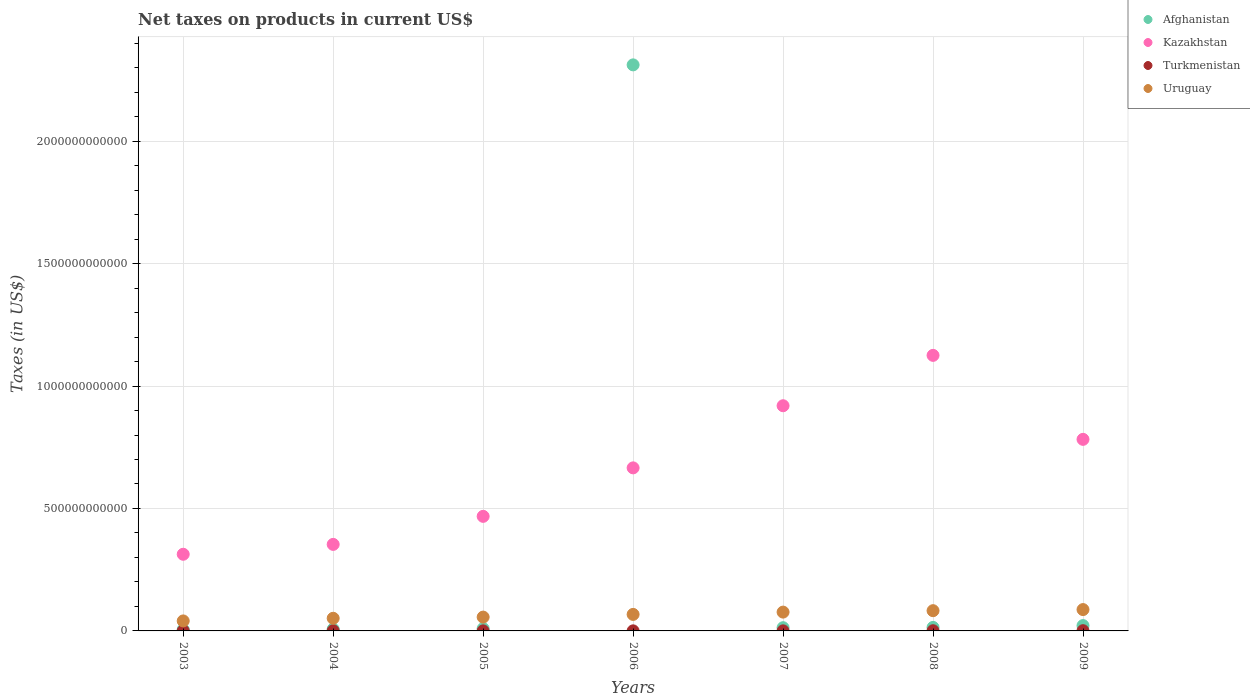What is the net taxes on products in Uruguay in 2004?
Your response must be concise. 5.16e+1. Across all years, what is the maximum net taxes on products in Uruguay?
Your answer should be compact. 8.72e+1. Across all years, what is the minimum net taxes on products in Turkmenistan?
Make the answer very short. 2.62e+08. In which year was the net taxes on products in Turkmenistan maximum?
Offer a very short reply. 2009. In which year was the net taxes on products in Uruguay minimum?
Keep it short and to the point. 2003. What is the total net taxes on products in Kazakhstan in the graph?
Offer a very short reply. 4.63e+12. What is the difference between the net taxes on products in Afghanistan in 2003 and that in 2006?
Your answer should be compact. -2.31e+12. What is the difference between the net taxes on products in Kazakhstan in 2003 and the net taxes on products in Turkmenistan in 2008?
Provide a short and direct response. 3.12e+11. What is the average net taxes on products in Kazakhstan per year?
Ensure brevity in your answer.  6.61e+11. In the year 2005, what is the difference between the net taxes on products in Kazakhstan and net taxes on products in Uruguay?
Make the answer very short. 4.11e+11. In how many years, is the net taxes on products in Kazakhstan greater than 1900000000000 US$?
Offer a terse response. 0. What is the ratio of the net taxes on products in Kazakhstan in 2008 to that in 2009?
Keep it short and to the point. 1.44. Is the net taxes on products in Turkmenistan in 2005 less than that in 2007?
Give a very brief answer. Yes. What is the difference between the highest and the second highest net taxes on products in Turkmenistan?
Your response must be concise. 8.25e+07. What is the difference between the highest and the lowest net taxes on products in Turkmenistan?
Provide a short and direct response. 6.44e+08. Is it the case that in every year, the sum of the net taxes on products in Uruguay and net taxes on products in Afghanistan  is greater than the net taxes on products in Turkmenistan?
Provide a succinct answer. Yes. Does the net taxes on products in Turkmenistan monotonically increase over the years?
Provide a short and direct response. No. Is the net taxes on products in Kazakhstan strictly greater than the net taxes on products in Uruguay over the years?
Offer a very short reply. Yes. How many years are there in the graph?
Provide a short and direct response. 7. What is the difference between two consecutive major ticks on the Y-axis?
Your answer should be compact. 5.00e+11. Does the graph contain grids?
Provide a short and direct response. Yes. Where does the legend appear in the graph?
Give a very brief answer. Top right. How many legend labels are there?
Keep it short and to the point. 4. How are the legend labels stacked?
Provide a short and direct response. Vertical. What is the title of the graph?
Your answer should be compact. Net taxes on products in current US$. Does "Palau" appear as one of the legend labels in the graph?
Your answer should be compact. No. What is the label or title of the Y-axis?
Provide a succinct answer. Taxes (in US$). What is the Taxes (in US$) in Afghanistan in 2003?
Give a very brief answer. 5.37e+09. What is the Taxes (in US$) of Kazakhstan in 2003?
Ensure brevity in your answer.  3.13e+11. What is the Taxes (in US$) in Turkmenistan in 2003?
Your answer should be compact. 6.87e+08. What is the Taxes (in US$) in Uruguay in 2003?
Keep it short and to the point. 4.08e+1. What is the Taxes (in US$) in Afghanistan in 2004?
Provide a short and direct response. 7.35e+09. What is the Taxes (in US$) in Kazakhstan in 2004?
Make the answer very short. 3.53e+11. What is the Taxes (in US$) in Turkmenistan in 2004?
Provide a succinct answer. 8.24e+08. What is the Taxes (in US$) in Uruguay in 2004?
Provide a short and direct response. 5.16e+1. What is the Taxes (in US$) in Afghanistan in 2005?
Make the answer very short. 9.45e+09. What is the Taxes (in US$) in Kazakhstan in 2005?
Make the answer very short. 4.68e+11. What is the Taxes (in US$) of Turkmenistan in 2005?
Offer a very short reply. 2.62e+08. What is the Taxes (in US$) of Uruguay in 2005?
Make the answer very short. 5.64e+1. What is the Taxes (in US$) of Afghanistan in 2006?
Provide a short and direct response. 2.31e+12. What is the Taxes (in US$) in Kazakhstan in 2006?
Your answer should be compact. 6.66e+11. What is the Taxes (in US$) in Turkmenistan in 2006?
Your answer should be compact. 3.14e+08. What is the Taxes (in US$) in Uruguay in 2006?
Provide a succinct answer. 6.74e+1. What is the Taxes (in US$) in Afghanistan in 2007?
Offer a very short reply. 1.32e+1. What is the Taxes (in US$) of Kazakhstan in 2007?
Offer a very short reply. 9.20e+11. What is the Taxes (in US$) of Turkmenistan in 2007?
Provide a short and direct response. 3.09e+08. What is the Taxes (in US$) of Uruguay in 2007?
Ensure brevity in your answer.  7.68e+1. What is the Taxes (in US$) of Afghanistan in 2008?
Provide a succinct answer. 1.43e+1. What is the Taxes (in US$) of Kazakhstan in 2008?
Keep it short and to the point. 1.13e+12. What is the Taxes (in US$) of Turkmenistan in 2008?
Your answer should be compact. 7.51e+08. What is the Taxes (in US$) in Uruguay in 2008?
Ensure brevity in your answer.  8.27e+1. What is the Taxes (in US$) in Afghanistan in 2009?
Your answer should be very brief. 2.18e+1. What is the Taxes (in US$) in Kazakhstan in 2009?
Make the answer very short. 7.82e+11. What is the Taxes (in US$) in Turkmenistan in 2009?
Offer a terse response. 9.07e+08. What is the Taxes (in US$) in Uruguay in 2009?
Offer a terse response. 8.72e+1. Across all years, what is the maximum Taxes (in US$) of Afghanistan?
Your answer should be very brief. 2.31e+12. Across all years, what is the maximum Taxes (in US$) in Kazakhstan?
Ensure brevity in your answer.  1.13e+12. Across all years, what is the maximum Taxes (in US$) of Turkmenistan?
Offer a terse response. 9.07e+08. Across all years, what is the maximum Taxes (in US$) of Uruguay?
Ensure brevity in your answer.  8.72e+1. Across all years, what is the minimum Taxes (in US$) in Afghanistan?
Give a very brief answer. 5.37e+09. Across all years, what is the minimum Taxes (in US$) in Kazakhstan?
Make the answer very short. 3.13e+11. Across all years, what is the minimum Taxes (in US$) of Turkmenistan?
Your answer should be compact. 2.62e+08. Across all years, what is the minimum Taxes (in US$) in Uruguay?
Offer a terse response. 4.08e+1. What is the total Taxes (in US$) of Afghanistan in the graph?
Make the answer very short. 2.38e+12. What is the total Taxes (in US$) of Kazakhstan in the graph?
Provide a short and direct response. 4.63e+12. What is the total Taxes (in US$) in Turkmenistan in the graph?
Provide a short and direct response. 4.05e+09. What is the total Taxes (in US$) of Uruguay in the graph?
Your answer should be compact. 4.63e+11. What is the difference between the Taxes (in US$) in Afghanistan in 2003 and that in 2004?
Your answer should be compact. -1.98e+09. What is the difference between the Taxes (in US$) in Kazakhstan in 2003 and that in 2004?
Ensure brevity in your answer.  -4.03e+1. What is the difference between the Taxes (in US$) in Turkmenistan in 2003 and that in 2004?
Offer a terse response. -1.38e+08. What is the difference between the Taxes (in US$) in Uruguay in 2003 and that in 2004?
Provide a succinct answer. -1.08e+1. What is the difference between the Taxes (in US$) of Afghanistan in 2003 and that in 2005?
Provide a succinct answer. -4.08e+09. What is the difference between the Taxes (in US$) in Kazakhstan in 2003 and that in 2005?
Ensure brevity in your answer.  -1.55e+11. What is the difference between the Taxes (in US$) of Turkmenistan in 2003 and that in 2005?
Provide a succinct answer. 4.24e+08. What is the difference between the Taxes (in US$) of Uruguay in 2003 and that in 2005?
Your response must be concise. -1.56e+1. What is the difference between the Taxes (in US$) in Afghanistan in 2003 and that in 2006?
Keep it short and to the point. -2.31e+12. What is the difference between the Taxes (in US$) in Kazakhstan in 2003 and that in 2006?
Keep it short and to the point. -3.53e+11. What is the difference between the Taxes (in US$) of Turkmenistan in 2003 and that in 2006?
Keep it short and to the point. 3.73e+08. What is the difference between the Taxes (in US$) in Uruguay in 2003 and that in 2006?
Provide a short and direct response. -2.66e+1. What is the difference between the Taxes (in US$) of Afghanistan in 2003 and that in 2007?
Provide a succinct answer. -7.82e+09. What is the difference between the Taxes (in US$) of Kazakhstan in 2003 and that in 2007?
Ensure brevity in your answer.  -6.07e+11. What is the difference between the Taxes (in US$) in Turkmenistan in 2003 and that in 2007?
Ensure brevity in your answer.  3.77e+08. What is the difference between the Taxes (in US$) in Uruguay in 2003 and that in 2007?
Your answer should be compact. -3.60e+1. What is the difference between the Taxes (in US$) of Afghanistan in 2003 and that in 2008?
Give a very brief answer. -8.96e+09. What is the difference between the Taxes (in US$) of Kazakhstan in 2003 and that in 2008?
Give a very brief answer. -8.12e+11. What is the difference between the Taxes (in US$) of Turkmenistan in 2003 and that in 2008?
Provide a succinct answer. -6.40e+07. What is the difference between the Taxes (in US$) of Uruguay in 2003 and that in 2008?
Offer a terse response. -4.18e+1. What is the difference between the Taxes (in US$) in Afghanistan in 2003 and that in 2009?
Your answer should be very brief. -1.64e+1. What is the difference between the Taxes (in US$) in Kazakhstan in 2003 and that in 2009?
Provide a succinct answer. -4.69e+11. What is the difference between the Taxes (in US$) of Turkmenistan in 2003 and that in 2009?
Keep it short and to the point. -2.20e+08. What is the difference between the Taxes (in US$) of Uruguay in 2003 and that in 2009?
Give a very brief answer. -4.63e+1. What is the difference between the Taxes (in US$) of Afghanistan in 2004 and that in 2005?
Your answer should be very brief. -2.10e+09. What is the difference between the Taxes (in US$) in Kazakhstan in 2004 and that in 2005?
Ensure brevity in your answer.  -1.15e+11. What is the difference between the Taxes (in US$) in Turkmenistan in 2004 and that in 2005?
Ensure brevity in your answer.  5.62e+08. What is the difference between the Taxes (in US$) of Uruguay in 2004 and that in 2005?
Give a very brief answer. -4.84e+09. What is the difference between the Taxes (in US$) in Afghanistan in 2004 and that in 2006?
Keep it short and to the point. -2.30e+12. What is the difference between the Taxes (in US$) in Kazakhstan in 2004 and that in 2006?
Your answer should be compact. -3.13e+11. What is the difference between the Taxes (in US$) of Turkmenistan in 2004 and that in 2006?
Your answer should be compact. 5.11e+08. What is the difference between the Taxes (in US$) of Uruguay in 2004 and that in 2006?
Make the answer very short. -1.58e+1. What is the difference between the Taxes (in US$) in Afghanistan in 2004 and that in 2007?
Offer a very short reply. -5.85e+09. What is the difference between the Taxes (in US$) in Kazakhstan in 2004 and that in 2007?
Offer a very short reply. -5.66e+11. What is the difference between the Taxes (in US$) in Turkmenistan in 2004 and that in 2007?
Provide a short and direct response. 5.15e+08. What is the difference between the Taxes (in US$) of Uruguay in 2004 and that in 2007?
Your response must be concise. -2.52e+1. What is the difference between the Taxes (in US$) in Afghanistan in 2004 and that in 2008?
Give a very brief answer. -6.98e+09. What is the difference between the Taxes (in US$) of Kazakhstan in 2004 and that in 2008?
Provide a short and direct response. -7.72e+11. What is the difference between the Taxes (in US$) of Turkmenistan in 2004 and that in 2008?
Ensure brevity in your answer.  7.36e+07. What is the difference between the Taxes (in US$) of Uruguay in 2004 and that in 2008?
Keep it short and to the point. -3.10e+1. What is the difference between the Taxes (in US$) in Afghanistan in 2004 and that in 2009?
Provide a short and direct response. -1.44e+1. What is the difference between the Taxes (in US$) in Kazakhstan in 2004 and that in 2009?
Your answer should be compact. -4.29e+11. What is the difference between the Taxes (in US$) in Turkmenistan in 2004 and that in 2009?
Keep it short and to the point. -8.25e+07. What is the difference between the Taxes (in US$) of Uruguay in 2004 and that in 2009?
Provide a short and direct response. -3.56e+1. What is the difference between the Taxes (in US$) in Afghanistan in 2005 and that in 2006?
Your answer should be compact. -2.30e+12. What is the difference between the Taxes (in US$) in Kazakhstan in 2005 and that in 2006?
Your answer should be compact. -1.98e+11. What is the difference between the Taxes (in US$) of Turkmenistan in 2005 and that in 2006?
Make the answer very short. -5.12e+07. What is the difference between the Taxes (in US$) of Uruguay in 2005 and that in 2006?
Keep it short and to the point. -1.10e+1. What is the difference between the Taxes (in US$) of Afghanistan in 2005 and that in 2007?
Provide a succinct answer. -3.75e+09. What is the difference between the Taxes (in US$) in Kazakhstan in 2005 and that in 2007?
Offer a very short reply. -4.52e+11. What is the difference between the Taxes (in US$) of Turkmenistan in 2005 and that in 2007?
Give a very brief answer. -4.68e+07. What is the difference between the Taxes (in US$) in Uruguay in 2005 and that in 2007?
Your answer should be compact. -2.04e+1. What is the difference between the Taxes (in US$) in Afghanistan in 2005 and that in 2008?
Keep it short and to the point. -4.88e+09. What is the difference between the Taxes (in US$) of Kazakhstan in 2005 and that in 2008?
Offer a terse response. -6.57e+11. What is the difference between the Taxes (in US$) in Turkmenistan in 2005 and that in 2008?
Offer a very short reply. -4.88e+08. What is the difference between the Taxes (in US$) of Uruguay in 2005 and that in 2008?
Ensure brevity in your answer.  -2.62e+1. What is the difference between the Taxes (in US$) in Afghanistan in 2005 and that in 2009?
Keep it short and to the point. -1.23e+1. What is the difference between the Taxes (in US$) in Kazakhstan in 2005 and that in 2009?
Your answer should be very brief. -3.14e+11. What is the difference between the Taxes (in US$) of Turkmenistan in 2005 and that in 2009?
Keep it short and to the point. -6.44e+08. What is the difference between the Taxes (in US$) of Uruguay in 2005 and that in 2009?
Make the answer very short. -3.07e+1. What is the difference between the Taxes (in US$) of Afghanistan in 2006 and that in 2007?
Your response must be concise. 2.30e+12. What is the difference between the Taxes (in US$) of Kazakhstan in 2006 and that in 2007?
Keep it short and to the point. -2.54e+11. What is the difference between the Taxes (in US$) in Turkmenistan in 2006 and that in 2007?
Ensure brevity in your answer.  4.40e+06. What is the difference between the Taxes (in US$) of Uruguay in 2006 and that in 2007?
Your response must be concise. -9.42e+09. What is the difference between the Taxes (in US$) of Afghanistan in 2006 and that in 2008?
Give a very brief answer. 2.30e+12. What is the difference between the Taxes (in US$) of Kazakhstan in 2006 and that in 2008?
Provide a succinct answer. -4.59e+11. What is the difference between the Taxes (in US$) in Turkmenistan in 2006 and that in 2008?
Give a very brief answer. -4.37e+08. What is the difference between the Taxes (in US$) of Uruguay in 2006 and that in 2008?
Your answer should be compact. -1.52e+1. What is the difference between the Taxes (in US$) in Afghanistan in 2006 and that in 2009?
Offer a terse response. 2.29e+12. What is the difference between the Taxes (in US$) of Kazakhstan in 2006 and that in 2009?
Provide a succinct answer. -1.16e+11. What is the difference between the Taxes (in US$) in Turkmenistan in 2006 and that in 2009?
Your response must be concise. -5.93e+08. What is the difference between the Taxes (in US$) in Uruguay in 2006 and that in 2009?
Offer a terse response. -1.97e+1. What is the difference between the Taxes (in US$) of Afghanistan in 2007 and that in 2008?
Your response must be concise. -1.14e+09. What is the difference between the Taxes (in US$) of Kazakhstan in 2007 and that in 2008?
Make the answer very short. -2.06e+11. What is the difference between the Taxes (in US$) of Turkmenistan in 2007 and that in 2008?
Make the answer very short. -4.41e+08. What is the difference between the Taxes (in US$) of Uruguay in 2007 and that in 2008?
Ensure brevity in your answer.  -5.82e+09. What is the difference between the Taxes (in US$) of Afghanistan in 2007 and that in 2009?
Give a very brief answer. -8.59e+09. What is the difference between the Taxes (in US$) in Kazakhstan in 2007 and that in 2009?
Your answer should be very brief. 1.37e+11. What is the difference between the Taxes (in US$) in Turkmenistan in 2007 and that in 2009?
Make the answer very short. -5.98e+08. What is the difference between the Taxes (in US$) of Uruguay in 2007 and that in 2009?
Keep it short and to the point. -1.03e+1. What is the difference between the Taxes (in US$) in Afghanistan in 2008 and that in 2009?
Provide a succinct answer. -7.45e+09. What is the difference between the Taxes (in US$) in Kazakhstan in 2008 and that in 2009?
Your response must be concise. 3.43e+11. What is the difference between the Taxes (in US$) in Turkmenistan in 2008 and that in 2009?
Your response must be concise. -1.56e+08. What is the difference between the Taxes (in US$) of Uruguay in 2008 and that in 2009?
Provide a succinct answer. -4.51e+09. What is the difference between the Taxes (in US$) of Afghanistan in 2003 and the Taxes (in US$) of Kazakhstan in 2004?
Offer a very short reply. -3.48e+11. What is the difference between the Taxes (in US$) of Afghanistan in 2003 and the Taxes (in US$) of Turkmenistan in 2004?
Keep it short and to the point. 4.54e+09. What is the difference between the Taxes (in US$) in Afghanistan in 2003 and the Taxes (in US$) in Uruguay in 2004?
Your answer should be compact. -4.62e+1. What is the difference between the Taxes (in US$) of Kazakhstan in 2003 and the Taxes (in US$) of Turkmenistan in 2004?
Offer a terse response. 3.12e+11. What is the difference between the Taxes (in US$) in Kazakhstan in 2003 and the Taxes (in US$) in Uruguay in 2004?
Provide a short and direct response. 2.61e+11. What is the difference between the Taxes (in US$) of Turkmenistan in 2003 and the Taxes (in US$) of Uruguay in 2004?
Ensure brevity in your answer.  -5.09e+1. What is the difference between the Taxes (in US$) of Afghanistan in 2003 and the Taxes (in US$) of Kazakhstan in 2005?
Ensure brevity in your answer.  -4.62e+11. What is the difference between the Taxes (in US$) of Afghanistan in 2003 and the Taxes (in US$) of Turkmenistan in 2005?
Ensure brevity in your answer.  5.11e+09. What is the difference between the Taxes (in US$) of Afghanistan in 2003 and the Taxes (in US$) of Uruguay in 2005?
Make the answer very short. -5.11e+1. What is the difference between the Taxes (in US$) of Kazakhstan in 2003 and the Taxes (in US$) of Turkmenistan in 2005?
Provide a succinct answer. 3.13e+11. What is the difference between the Taxes (in US$) of Kazakhstan in 2003 and the Taxes (in US$) of Uruguay in 2005?
Make the answer very short. 2.57e+11. What is the difference between the Taxes (in US$) of Turkmenistan in 2003 and the Taxes (in US$) of Uruguay in 2005?
Ensure brevity in your answer.  -5.58e+1. What is the difference between the Taxes (in US$) of Afghanistan in 2003 and the Taxes (in US$) of Kazakhstan in 2006?
Keep it short and to the point. -6.60e+11. What is the difference between the Taxes (in US$) in Afghanistan in 2003 and the Taxes (in US$) in Turkmenistan in 2006?
Provide a short and direct response. 5.06e+09. What is the difference between the Taxes (in US$) of Afghanistan in 2003 and the Taxes (in US$) of Uruguay in 2006?
Offer a very short reply. -6.20e+1. What is the difference between the Taxes (in US$) of Kazakhstan in 2003 and the Taxes (in US$) of Turkmenistan in 2006?
Your answer should be compact. 3.13e+11. What is the difference between the Taxes (in US$) of Kazakhstan in 2003 and the Taxes (in US$) of Uruguay in 2006?
Give a very brief answer. 2.46e+11. What is the difference between the Taxes (in US$) of Turkmenistan in 2003 and the Taxes (in US$) of Uruguay in 2006?
Your response must be concise. -6.67e+1. What is the difference between the Taxes (in US$) in Afghanistan in 2003 and the Taxes (in US$) in Kazakhstan in 2007?
Give a very brief answer. -9.14e+11. What is the difference between the Taxes (in US$) of Afghanistan in 2003 and the Taxes (in US$) of Turkmenistan in 2007?
Provide a short and direct response. 5.06e+09. What is the difference between the Taxes (in US$) in Afghanistan in 2003 and the Taxes (in US$) in Uruguay in 2007?
Offer a terse response. -7.15e+1. What is the difference between the Taxes (in US$) of Kazakhstan in 2003 and the Taxes (in US$) of Turkmenistan in 2007?
Make the answer very short. 3.13e+11. What is the difference between the Taxes (in US$) of Kazakhstan in 2003 and the Taxes (in US$) of Uruguay in 2007?
Provide a succinct answer. 2.36e+11. What is the difference between the Taxes (in US$) in Turkmenistan in 2003 and the Taxes (in US$) in Uruguay in 2007?
Provide a short and direct response. -7.61e+1. What is the difference between the Taxes (in US$) of Afghanistan in 2003 and the Taxes (in US$) of Kazakhstan in 2008?
Provide a succinct answer. -1.12e+12. What is the difference between the Taxes (in US$) of Afghanistan in 2003 and the Taxes (in US$) of Turkmenistan in 2008?
Your answer should be compact. 4.62e+09. What is the difference between the Taxes (in US$) of Afghanistan in 2003 and the Taxes (in US$) of Uruguay in 2008?
Give a very brief answer. -7.73e+1. What is the difference between the Taxes (in US$) in Kazakhstan in 2003 and the Taxes (in US$) in Turkmenistan in 2008?
Your response must be concise. 3.12e+11. What is the difference between the Taxes (in US$) in Kazakhstan in 2003 and the Taxes (in US$) in Uruguay in 2008?
Provide a short and direct response. 2.30e+11. What is the difference between the Taxes (in US$) of Turkmenistan in 2003 and the Taxes (in US$) of Uruguay in 2008?
Keep it short and to the point. -8.20e+1. What is the difference between the Taxes (in US$) in Afghanistan in 2003 and the Taxes (in US$) in Kazakhstan in 2009?
Your answer should be very brief. -7.77e+11. What is the difference between the Taxes (in US$) of Afghanistan in 2003 and the Taxes (in US$) of Turkmenistan in 2009?
Give a very brief answer. 4.46e+09. What is the difference between the Taxes (in US$) of Afghanistan in 2003 and the Taxes (in US$) of Uruguay in 2009?
Offer a very short reply. -8.18e+1. What is the difference between the Taxes (in US$) of Kazakhstan in 2003 and the Taxes (in US$) of Turkmenistan in 2009?
Your answer should be compact. 3.12e+11. What is the difference between the Taxes (in US$) of Kazakhstan in 2003 and the Taxes (in US$) of Uruguay in 2009?
Give a very brief answer. 2.26e+11. What is the difference between the Taxes (in US$) of Turkmenistan in 2003 and the Taxes (in US$) of Uruguay in 2009?
Keep it short and to the point. -8.65e+1. What is the difference between the Taxes (in US$) of Afghanistan in 2004 and the Taxes (in US$) of Kazakhstan in 2005?
Make the answer very short. -4.61e+11. What is the difference between the Taxes (in US$) of Afghanistan in 2004 and the Taxes (in US$) of Turkmenistan in 2005?
Ensure brevity in your answer.  7.08e+09. What is the difference between the Taxes (in US$) of Afghanistan in 2004 and the Taxes (in US$) of Uruguay in 2005?
Provide a succinct answer. -4.91e+1. What is the difference between the Taxes (in US$) in Kazakhstan in 2004 and the Taxes (in US$) in Turkmenistan in 2005?
Provide a succinct answer. 3.53e+11. What is the difference between the Taxes (in US$) of Kazakhstan in 2004 and the Taxes (in US$) of Uruguay in 2005?
Provide a succinct answer. 2.97e+11. What is the difference between the Taxes (in US$) of Turkmenistan in 2004 and the Taxes (in US$) of Uruguay in 2005?
Offer a very short reply. -5.56e+1. What is the difference between the Taxes (in US$) of Afghanistan in 2004 and the Taxes (in US$) of Kazakhstan in 2006?
Provide a succinct answer. -6.58e+11. What is the difference between the Taxes (in US$) of Afghanistan in 2004 and the Taxes (in US$) of Turkmenistan in 2006?
Keep it short and to the point. 7.03e+09. What is the difference between the Taxes (in US$) of Afghanistan in 2004 and the Taxes (in US$) of Uruguay in 2006?
Provide a short and direct response. -6.01e+1. What is the difference between the Taxes (in US$) of Kazakhstan in 2004 and the Taxes (in US$) of Turkmenistan in 2006?
Make the answer very short. 3.53e+11. What is the difference between the Taxes (in US$) of Kazakhstan in 2004 and the Taxes (in US$) of Uruguay in 2006?
Offer a terse response. 2.86e+11. What is the difference between the Taxes (in US$) in Turkmenistan in 2004 and the Taxes (in US$) in Uruguay in 2006?
Provide a succinct answer. -6.66e+1. What is the difference between the Taxes (in US$) in Afghanistan in 2004 and the Taxes (in US$) in Kazakhstan in 2007?
Your answer should be compact. -9.12e+11. What is the difference between the Taxes (in US$) of Afghanistan in 2004 and the Taxes (in US$) of Turkmenistan in 2007?
Give a very brief answer. 7.04e+09. What is the difference between the Taxes (in US$) of Afghanistan in 2004 and the Taxes (in US$) of Uruguay in 2007?
Your response must be concise. -6.95e+1. What is the difference between the Taxes (in US$) in Kazakhstan in 2004 and the Taxes (in US$) in Turkmenistan in 2007?
Your answer should be very brief. 3.53e+11. What is the difference between the Taxes (in US$) in Kazakhstan in 2004 and the Taxes (in US$) in Uruguay in 2007?
Your answer should be compact. 2.76e+11. What is the difference between the Taxes (in US$) of Turkmenistan in 2004 and the Taxes (in US$) of Uruguay in 2007?
Ensure brevity in your answer.  -7.60e+1. What is the difference between the Taxes (in US$) of Afghanistan in 2004 and the Taxes (in US$) of Kazakhstan in 2008?
Provide a succinct answer. -1.12e+12. What is the difference between the Taxes (in US$) in Afghanistan in 2004 and the Taxes (in US$) in Turkmenistan in 2008?
Your answer should be very brief. 6.60e+09. What is the difference between the Taxes (in US$) in Afghanistan in 2004 and the Taxes (in US$) in Uruguay in 2008?
Make the answer very short. -7.53e+1. What is the difference between the Taxes (in US$) in Kazakhstan in 2004 and the Taxes (in US$) in Turkmenistan in 2008?
Offer a very short reply. 3.53e+11. What is the difference between the Taxes (in US$) of Kazakhstan in 2004 and the Taxes (in US$) of Uruguay in 2008?
Make the answer very short. 2.71e+11. What is the difference between the Taxes (in US$) in Turkmenistan in 2004 and the Taxes (in US$) in Uruguay in 2008?
Your answer should be compact. -8.18e+1. What is the difference between the Taxes (in US$) of Afghanistan in 2004 and the Taxes (in US$) of Kazakhstan in 2009?
Your answer should be compact. -7.75e+11. What is the difference between the Taxes (in US$) in Afghanistan in 2004 and the Taxes (in US$) in Turkmenistan in 2009?
Your response must be concise. 6.44e+09. What is the difference between the Taxes (in US$) in Afghanistan in 2004 and the Taxes (in US$) in Uruguay in 2009?
Your answer should be very brief. -7.98e+1. What is the difference between the Taxes (in US$) of Kazakhstan in 2004 and the Taxes (in US$) of Turkmenistan in 2009?
Your answer should be very brief. 3.52e+11. What is the difference between the Taxes (in US$) of Kazakhstan in 2004 and the Taxes (in US$) of Uruguay in 2009?
Provide a short and direct response. 2.66e+11. What is the difference between the Taxes (in US$) of Turkmenistan in 2004 and the Taxes (in US$) of Uruguay in 2009?
Provide a short and direct response. -8.63e+1. What is the difference between the Taxes (in US$) in Afghanistan in 2005 and the Taxes (in US$) in Kazakhstan in 2006?
Ensure brevity in your answer.  -6.56e+11. What is the difference between the Taxes (in US$) in Afghanistan in 2005 and the Taxes (in US$) in Turkmenistan in 2006?
Provide a succinct answer. 9.13e+09. What is the difference between the Taxes (in US$) in Afghanistan in 2005 and the Taxes (in US$) in Uruguay in 2006?
Offer a terse response. -5.80e+1. What is the difference between the Taxes (in US$) of Kazakhstan in 2005 and the Taxes (in US$) of Turkmenistan in 2006?
Provide a succinct answer. 4.68e+11. What is the difference between the Taxes (in US$) of Kazakhstan in 2005 and the Taxes (in US$) of Uruguay in 2006?
Offer a very short reply. 4.00e+11. What is the difference between the Taxes (in US$) in Turkmenistan in 2005 and the Taxes (in US$) in Uruguay in 2006?
Ensure brevity in your answer.  -6.72e+1. What is the difference between the Taxes (in US$) of Afghanistan in 2005 and the Taxes (in US$) of Kazakhstan in 2007?
Offer a terse response. -9.10e+11. What is the difference between the Taxes (in US$) in Afghanistan in 2005 and the Taxes (in US$) in Turkmenistan in 2007?
Ensure brevity in your answer.  9.14e+09. What is the difference between the Taxes (in US$) of Afghanistan in 2005 and the Taxes (in US$) of Uruguay in 2007?
Make the answer very short. -6.74e+1. What is the difference between the Taxes (in US$) in Kazakhstan in 2005 and the Taxes (in US$) in Turkmenistan in 2007?
Make the answer very short. 4.68e+11. What is the difference between the Taxes (in US$) in Kazakhstan in 2005 and the Taxes (in US$) in Uruguay in 2007?
Keep it short and to the point. 3.91e+11. What is the difference between the Taxes (in US$) in Turkmenistan in 2005 and the Taxes (in US$) in Uruguay in 2007?
Offer a terse response. -7.66e+1. What is the difference between the Taxes (in US$) of Afghanistan in 2005 and the Taxes (in US$) of Kazakhstan in 2008?
Offer a terse response. -1.12e+12. What is the difference between the Taxes (in US$) in Afghanistan in 2005 and the Taxes (in US$) in Turkmenistan in 2008?
Offer a terse response. 8.70e+09. What is the difference between the Taxes (in US$) in Afghanistan in 2005 and the Taxes (in US$) in Uruguay in 2008?
Offer a terse response. -7.32e+1. What is the difference between the Taxes (in US$) in Kazakhstan in 2005 and the Taxes (in US$) in Turkmenistan in 2008?
Keep it short and to the point. 4.67e+11. What is the difference between the Taxes (in US$) of Kazakhstan in 2005 and the Taxes (in US$) of Uruguay in 2008?
Offer a very short reply. 3.85e+11. What is the difference between the Taxes (in US$) of Turkmenistan in 2005 and the Taxes (in US$) of Uruguay in 2008?
Ensure brevity in your answer.  -8.24e+1. What is the difference between the Taxes (in US$) in Afghanistan in 2005 and the Taxes (in US$) in Kazakhstan in 2009?
Your response must be concise. -7.73e+11. What is the difference between the Taxes (in US$) of Afghanistan in 2005 and the Taxes (in US$) of Turkmenistan in 2009?
Your answer should be compact. 8.54e+09. What is the difference between the Taxes (in US$) in Afghanistan in 2005 and the Taxes (in US$) in Uruguay in 2009?
Give a very brief answer. -7.77e+1. What is the difference between the Taxes (in US$) of Kazakhstan in 2005 and the Taxes (in US$) of Turkmenistan in 2009?
Provide a short and direct response. 4.67e+11. What is the difference between the Taxes (in US$) in Kazakhstan in 2005 and the Taxes (in US$) in Uruguay in 2009?
Your response must be concise. 3.81e+11. What is the difference between the Taxes (in US$) of Turkmenistan in 2005 and the Taxes (in US$) of Uruguay in 2009?
Your answer should be compact. -8.69e+1. What is the difference between the Taxes (in US$) in Afghanistan in 2006 and the Taxes (in US$) in Kazakhstan in 2007?
Your answer should be very brief. 1.39e+12. What is the difference between the Taxes (in US$) of Afghanistan in 2006 and the Taxes (in US$) of Turkmenistan in 2007?
Your response must be concise. 2.31e+12. What is the difference between the Taxes (in US$) in Afghanistan in 2006 and the Taxes (in US$) in Uruguay in 2007?
Offer a terse response. 2.23e+12. What is the difference between the Taxes (in US$) in Kazakhstan in 2006 and the Taxes (in US$) in Turkmenistan in 2007?
Your answer should be compact. 6.66e+11. What is the difference between the Taxes (in US$) in Kazakhstan in 2006 and the Taxes (in US$) in Uruguay in 2007?
Provide a short and direct response. 5.89e+11. What is the difference between the Taxes (in US$) of Turkmenistan in 2006 and the Taxes (in US$) of Uruguay in 2007?
Make the answer very short. -7.65e+1. What is the difference between the Taxes (in US$) of Afghanistan in 2006 and the Taxes (in US$) of Kazakhstan in 2008?
Provide a succinct answer. 1.19e+12. What is the difference between the Taxes (in US$) in Afghanistan in 2006 and the Taxes (in US$) in Turkmenistan in 2008?
Your answer should be compact. 2.31e+12. What is the difference between the Taxes (in US$) in Afghanistan in 2006 and the Taxes (in US$) in Uruguay in 2008?
Offer a very short reply. 2.23e+12. What is the difference between the Taxes (in US$) of Kazakhstan in 2006 and the Taxes (in US$) of Turkmenistan in 2008?
Provide a succinct answer. 6.65e+11. What is the difference between the Taxes (in US$) in Kazakhstan in 2006 and the Taxes (in US$) in Uruguay in 2008?
Your answer should be very brief. 5.83e+11. What is the difference between the Taxes (in US$) in Turkmenistan in 2006 and the Taxes (in US$) in Uruguay in 2008?
Offer a terse response. -8.23e+1. What is the difference between the Taxes (in US$) in Afghanistan in 2006 and the Taxes (in US$) in Kazakhstan in 2009?
Your response must be concise. 1.53e+12. What is the difference between the Taxes (in US$) in Afghanistan in 2006 and the Taxes (in US$) in Turkmenistan in 2009?
Give a very brief answer. 2.31e+12. What is the difference between the Taxes (in US$) of Afghanistan in 2006 and the Taxes (in US$) of Uruguay in 2009?
Offer a very short reply. 2.22e+12. What is the difference between the Taxes (in US$) in Kazakhstan in 2006 and the Taxes (in US$) in Turkmenistan in 2009?
Offer a terse response. 6.65e+11. What is the difference between the Taxes (in US$) of Kazakhstan in 2006 and the Taxes (in US$) of Uruguay in 2009?
Make the answer very short. 5.79e+11. What is the difference between the Taxes (in US$) of Turkmenistan in 2006 and the Taxes (in US$) of Uruguay in 2009?
Provide a succinct answer. -8.69e+1. What is the difference between the Taxes (in US$) in Afghanistan in 2007 and the Taxes (in US$) in Kazakhstan in 2008?
Give a very brief answer. -1.11e+12. What is the difference between the Taxes (in US$) in Afghanistan in 2007 and the Taxes (in US$) in Turkmenistan in 2008?
Provide a succinct answer. 1.24e+1. What is the difference between the Taxes (in US$) in Afghanistan in 2007 and the Taxes (in US$) in Uruguay in 2008?
Ensure brevity in your answer.  -6.95e+1. What is the difference between the Taxes (in US$) of Kazakhstan in 2007 and the Taxes (in US$) of Turkmenistan in 2008?
Your answer should be compact. 9.19e+11. What is the difference between the Taxes (in US$) in Kazakhstan in 2007 and the Taxes (in US$) in Uruguay in 2008?
Ensure brevity in your answer.  8.37e+11. What is the difference between the Taxes (in US$) of Turkmenistan in 2007 and the Taxes (in US$) of Uruguay in 2008?
Give a very brief answer. -8.23e+1. What is the difference between the Taxes (in US$) of Afghanistan in 2007 and the Taxes (in US$) of Kazakhstan in 2009?
Make the answer very short. -7.69e+11. What is the difference between the Taxes (in US$) of Afghanistan in 2007 and the Taxes (in US$) of Turkmenistan in 2009?
Provide a short and direct response. 1.23e+1. What is the difference between the Taxes (in US$) of Afghanistan in 2007 and the Taxes (in US$) of Uruguay in 2009?
Keep it short and to the point. -7.40e+1. What is the difference between the Taxes (in US$) of Kazakhstan in 2007 and the Taxes (in US$) of Turkmenistan in 2009?
Offer a terse response. 9.19e+11. What is the difference between the Taxes (in US$) in Kazakhstan in 2007 and the Taxes (in US$) in Uruguay in 2009?
Ensure brevity in your answer.  8.32e+11. What is the difference between the Taxes (in US$) of Turkmenistan in 2007 and the Taxes (in US$) of Uruguay in 2009?
Your answer should be very brief. -8.69e+1. What is the difference between the Taxes (in US$) of Afghanistan in 2008 and the Taxes (in US$) of Kazakhstan in 2009?
Provide a short and direct response. -7.68e+11. What is the difference between the Taxes (in US$) of Afghanistan in 2008 and the Taxes (in US$) of Turkmenistan in 2009?
Your response must be concise. 1.34e+1. What is the difference between the Taxes (in US$) of Afghanistan in 2008 and the Taxes (in US$) of Uruguay in 2009?
Give a very brief answer. -7.28e+1. What is the difference between the Taxes (in US$) of Kazakhstan in 2008 and the Taxes (in US$) of Turkmenistan in 2009?
Make the answer very short. 1.12e+12. What is the difference between the Taxes (in US$) in Kazakhstan in 2008 and the Taxes (in US$) in Uruguay in 2009?
Give a very brief answer. 1.04e+12. What is the difference between the Taxes (in US$) of Turkmenistan in 2008 and the Taxes (in US$) of Uruguay in 2009?
Provide a short and direct response. -8.64e+1. What is the average Taxes (in US$) in Afghanistan per year?
Give a very brief answer. 3.40e+11. What is the average Taxes (in US$) in Kazakhstan per year?
Ensure brevity in your answer.  6.61e+11. What is the average Taxes (in US$) of Turkmenistan per year?
Your answer should be compact. 5.79e+08. What is the average Taxes (in US$) in Uruguay per year?
Your response must be concise. 6.61e+1. In the year 2003, what is the difference between the Taxes (in US$) of Afghanistan and Taxes (in US$) of Kazakhstan?
Your answer should be very brief. -3.08e+11. In the year 2003, what is the difference between the Taxes (in US$) in Afghanistan and Taxes (in US$) in Turkmenistan?
Your answer should be compact. 4.68e+09. In the year 2003, what is the difference between the Taxes (in US$) in Afghanistan and Taxes (in US$) in Uruguay?
Your answer should be very brief. -3.55e+1. In the year 2003, what is the difference between the Taxes (in US$) in Kazakhstan and Taxes (in US$) in Turkmenistan?
Keep it short and to the point. 3.12e+11. In the year 2003, what is the difference between the Taxes (in US$) in Kazakhstan and Taxes (in US$) in Uruguay?
Give a very brief answer. 2.72e+11. In the year 2003, what is the difference between the Taxes (in US$) in Turkmenistan and Taxes (in US$) in Uruguay?
Your answer should be very brief. -4.01e+1. In the year 2004, what is the difference between the Taxes (in US$) of Afghanistan and Taxes (in US$) of Kazakhstan?
Provide a short and direct response. -3.46e+11. In the year 2004, what is the difference between the Taxes (in US$) of Afghanistan and Taxes (in US$) of Turkmenistan?
Offer a terse response. 6.52e+09. In the year 2004, what is the difference between the Taxes (in US$) of Afghanistan and Taxes (in US$) of Uruguay?
Offer a terse response. -4.43e+1. In the year 2004, what is the difference between the Taxes (in US$) of Kazakhstan and Taxes (in US$) of Turkmenistan?
Make the answer very short. 3.52e+11. In the year 2004, what is the difference between the Taxes (in US$) of Kazakhstan and Taxes (in US$) of Uruguay?
Provide a succinct answer. 3.02e+11. In the year 2004, what is the difference between the Taxes (in US$) in Turkmenistan and Taxes (in US$) in Uruguay?
Your answer should be compact. -5.08e+1. In the year 2005, what is the difference between the Taxes (in US$) in Afghanistan and Taxes (in US$) in Kazakhstan?
Keep it short and to the point. -4.58e+11. In the year 2005, what is the difference between the Taxes (in US$) in Afghanistan and Taxes (in US$) in Turkmenistan?
Give a very brief answer. 9.18e+09. In the year 2005, what is the difference between the Taxes (in US$) of Afghanistan and Taxes (in US$) of Uruguay?
Your response must be concise. -4.70e+1. In the year 2005, what is the difference between the Taxes (in US$) of Kazakhstan and Taxes (in US$) of Turkmenistan?
Offer a terse response. 4.68e+11. In the year 2005, what is the difference between the Taxes (in US$) of Kazakhstan and Taxes (in US$) of Uruguay?
Provide a short and direct response. 4.11e+11. In the year 2005, what is the difference between the Taxes (in US$) in Turkmenistan and Taxes (in US$) in Uruguay?
Offer a terse response. -5.62e+1. In the year 2006, what is the difference between the Taxes (in US$) of Afghanistan and Taxes (in US$) of Kazakhstan?
Give a very brief answer. 1.65e+12. In the year 2006, what is the difference between the Taxes (in US$) in Afghanistan and Taxes (in US$) in Turkmenistan?
Give a very brief answer. 2.31e+12. In the year 2006, what is the difference between the Taxes (in US$) in Afghanistan and Taxes (in US$) in Uruguay?
Provide a short and direct response. 2.24e+12. In the year 2006, what is the difference between the Taxes (in US$) of Kazakhstan and Taxes (in US$) of Turkmenistan?
Keep it short and to the point. 6.66e+11. In the year 2006, what is the difference between the Taxes (in US$) in Kazakhstan and Taxes (in US$) in Uruguay?
Offer a very short reply. 5.98e+11. In the year 2006, what is the difference between the Taxes (in US$) in Turkmenistan and Taxes (in US$) in Uruguay?
Provide a short and direct response. -6.71e+1. In the year 2007, what is the difference between the Taxes (in US$) in Afghanistan and Taxes (in US$) in Kazakhstan?
Keep it short and to the point. -9.06e+11. In the year 2007, what is the difference between the Taxes (in US$) in Afghanistan and Taxes (in US$) in Turkmenistan?
Provide a short and direct response. 1.29e+1. In the year 2007, what is the difference between the Taxes (in US$) in Afghanistan and Taxes (in US$) in Uruguay?
Your answer should be very brief. -6.36e+1. In the year 2007, what is the difference between the Taxes (in US$) of Kazakhstan and Taxes (in US$) of Turkmenistan?
Your answer should be very brief. 9.19e+11. In the year 2007, what is the difference between the Taxes (in US$) in Kazakhstan and Taxes (in US$) in Uruguay?
Your answer should be compact. 8.43e+11. In the year 2007, what is the difference between the Taxes (in US$) in Turkmenistan and Taxes (in US$) in Uruguay?
Make the answer very short. -7.65e+1. In the year 2008, what is the difference between the Taxes (in US$) in Afghanistan and Taxes (in US$) in Kazakhstan?
Provide a short and direct response. -1.11e+12. In the year 2008, what is the difference between the Taxes (in US$) of Afghanistan and Taxes (in US$) of Turkmenistan?
Provide a short and direct response. 1.36e+1. In the year 2008, what is the difference between the Taxes (in US$) of Afghanistan and Taxes (in US$) of Uruguay?
Offer a terse response. -6.83e+1. In the year 2008, what is the difference between the Taxes (in US$) of Kazakhstan and Taxes (in US$) of Turkmenistan?
Provide a short and direct response. 1.12e+12. In the year 2008, what is the difference between the Taxes (in US$) of Kazakhstan and Taxes (in US$) of Uruguay?
Provide a succinct answer. 1.04e+12. In the year 2008, what is the difference between the Taxes (in US$) in Turkmenistan and Taxes (in US$) in Uruguay?
Make the answer very short. -8.19e+1. In the year 2009, what is the difference between the Taxes (in US$) in Afghanistan and Taxes (in US$) in Kazakhstan?
Your response must be concise. -7.61e+11. In the year 2009, what is the difference between the Taxes (in US$) in Afghanistan and Taxes (in US$) in Turkmenistan?
Your answer should be compact. 2.09e+1. In the year 2009, what is the difference between the Taxes (in US$) of Afghanistan and Taxes (in US$) of Uruguay?
Your response must be concise. -6.54e+1. In the year 2009, what is the difference between the Taxes (in US$) in Kazakhstan and Taxes (in US$) in Turkmenistan?
Your response must be concise. 7.81e+11. In the year 2009, what is the difference between the Taxes (in US$) of Kazakhstan and Taxes (in US$) of Uruguay?
Ensure brevity in your answer.  6.95e+11. In the year 2009, what is the difference between the Taxes (in US$) in Turkmenistan and Taxes (in US$) in Uruguay?
Keep it short and to the point. -8.63e+1. What is the ratio of the Taxes (in US$) of Afghanistan in 2003 to that in 2004?
Offer a very short reply. 0.73. What is the ratio of the Taxes (in US$) in Kazakhstan in 2003 to that in 2004?
Keep it short and to the point. 0.89. What is the ratio of the Taxes (in US$) of Turkmenistan in 2003 to that in 2004?
Make the answer very short. 0.83. What is the ratio of the Taxes (in US$) in Uruguay in 2003 to that in 2004?
Ensure brevity in your answer.  0.79. What is the ratio of the Taxes (in US$) of Afghanistan in 2003 to that in 2005?
Your answer should be compact. 0.57. What is the ratio of the Taxes (in US$) in Kazakhstan in 2003 to that in 2005?
Your answer should be compact. 0.67. What is the ratio of the Taxes (in US$) in Turkmenistan in 2003 to that in 2005?
Offer a terse response. 2.62. What is the ratio of the Taxes (in US$) of Uruguay in 2003 to that in 2005?
Your response must be concise. 0.72. What is the ratio of the Taxes (in US$) in Afghanistan in 2003 to that in 2006?
Provide a succinct answer. 0. What is the ratio of the Taxes (in US$) of Kazakhstan in 2003 to that in 2006?
Offer a terse response. 0.47. What is the ratio of the Taxes (in US$) of Turkmenistan in 2003 to that in 2006?
Your answer should be very brief. 2.19. What is the ratio of the Taxes (in US$) of Uruguay in 2003 to that in 2006?
Offer a very short reply. 0.61. What is the ratio of the Taxes (in US$) of Afghanistan in 2003 to that in 2007?
Keep it short and to the point. 0.41. What is the ratio of the Taxes (in US$) in Kazakhstan in 2003 to that in 2007?
Ensure brevity in your answer.  0.34. What is the ratio of the Taxes (in US$) of Turkmenistan in 2003 to that in 2007?
Offer a terse response. 2.22. What is the ratio of the Taxes (in US$) of Uruguay in 2003 to that in 2007?
Give a very brief answer. 0.53. What is the ratio of the Taxes (in US$) of Afghanistan in 2003 to that in 2008?
Your answer should be compact. 0.37. What is the ratio of the Taxes (in US$) of Kazakhstan in 2003 to that in 2008?
Make the answer very short. 0.28. What is the ratio of the Taxes (in US$) of Turkmenistan in 2003 to that in 2008?
Provide a succinct answer. 0.91. What is the ratio of the Taxes (in US$) in Uruguay in 2003 to that in 2008?
Your answer should be very brief. 0.49. What is the ratio of the Taxes (in US$) of Afghanistan in 2003 to that in 2009?
Provide a succinct answer. 0.25. What is the ratio of the Taxes (in US$) in Kazakhstan in 2003 to that in 2009?
Offer a very short reply. 0.4. What is the ratio of the Taxes (in US$) in Turkmenistan in 2003 to that in 2009?
Your response must be concise. 0.76. What is the ratio of the Taxes (in US$) of Uruguay in 2003 to that in 2009?
Make the answer very short. 0.47. What is the ratio of the Taxes (in US$) of Afghanistan in 2004 to that in 2005?
Your answer should be very brief. 0.78. What is the ratio of the Taxes (in US$) in Kazakhstan in 2004 to that in 2005?
Offer a very short reply. 0.76. What is the ratio of the Taxes (in US$) of Turkmenistan in 2004 to that in 2005?
Provide a short and direct response. 3.14. What is the ratio of the Taxes (in US$) in Uruguay in 2004 to that in 2005?
Offer a terse response. 0.91. What is the ratio of the Taxes (in US$) in Afghanistan in 2004 to that in 2006?
Your answer should be very brief. 0. What is the ratio of the Taxes (in US$) of Kazakhstan in 2004 to that in 2006?
Provide a succinct answer. 0.53. What is the ratio of the Taxes (in US$) of Turkmenistan in 2004 to that in 2006?
Offer a very short reply. 2.63. What is the ratio of the Taxes (in US$) of Uruguay in 2004 to that in 2006?
Keep it short and to the point. 0.77. What is the ratio of the Taxes (in US$) of Afghanistan in 2004 to that in 2007?
Provide a succinct answer. 0.56. What is the ratio of the Taxes (in US$) of Kazakhstan in 2004 to that in 2007?
Your answer should be very brief. 0.38. What is the ratio of the Taxes (in US$) in Turkmenistan in 2004 to that in 2007?
Ensure brevity in your answer.  2.67. What is the ratio of the Taxes (in US$) of Uruguay in 2004 to that in 2007?
Give a very brief answer. 0.67. What is the ratio of the Taxes (in US$) of Afghanistan in 2004 to that in 2008?
Offer a very short reply. 0.51. What is the ratio of the Taxes (in US$) of Kazakhstan in 2004 to that in 2008?
Keep it short and to the point. 0.31. What is the ratio of the Taxes (in US$) in Turkmenistan in 2004 to that in 2008?
Provide a succinct answer. 1.1. What is the ratio of the Taxes (in US$) in Uruguay in 2004 to that in 2008?
Provide a succinct answer. 0.62. What is the ratio of the Taxes (in US$) of Afghanistan in 2004 to that in 2009?
Keep it short and to the point. 0.34. What is the ratio of the Taxes (in US$) in Kazakhstan in 2004 to that in 2009?
Provide a short and direct response. 0.45. What is the ratio of the Taxes (in US$) of Turkmenistan in 2004 to that in 2009?
Offer a very short reply. 0.91. What is the ratio of the Taxes (in US$) of Uruguay in 2004 to that in 2009?
Keep it short and to the point. 0.59. What is the ratio of the Taxes (in US$) of Afghanistan in 2005 to that in 2006?
Your answer should be compact. 0. What is the ratio of the Taxes (in US$) of Kazakhstan in 2005 to that in 2006?
Offer a very short reply. 0.7. What is the ratio of the Taxes (in US$) of Turkmenistan in 2005 to that in 2006?
Provide a succinct answer. 0.84. What is the ratio of the Taxes (in US$) in Uruguay in 2005 to that in 2006?
Your answer should be compact. 0.84. What is the ratio of the Taxes (in US$) in Afghanistan in 2005 to that in 2007?
Make the answer very short. 0.72. What is the ratio of the Taxes (in US$) of Kazakhstan in 2005 to that in 2007?
Offer a terse response. 0.51. What is the ratio of the Taxes (in US$) of Turkmenistan in 2005 to that in 2007?
Give a very brief answer. 0.85. What is the ratio of the Taxes (in US$) in Uruguay in 2005 to that in 2007?
Give a very brief answer. 0.73. What is the ratio of the Taxes (in US$) of Afghanistan in 2005 to that in 2008?
Make the answer very short. 0.66. What is the ratio of the Taxes (in US$) of Kazakhstan in 2005 to that in 2008?
Provide a short and direct response. 0.42. What is the ratio of the Taxes (in US$) of Turkmenistan in 2005 to that in 2008?
Your response must be concise. 0.35. What is the ratio of the Taxes (in US$) in Uruguay in 2005 to that in 2008?
Keep it short and to the point. 0.68. What is the ratio of the Taxes (in US$) of Afghanistan in 2005 to that in 2009?
Provide a succinct answer. 0.43. What is the ratio of the Taxes (in US$) in Kazakhstan in 2005 to that in 2009?
Your answer should be very brief. 0.6. What is the ratio of the Taxes (in US$) of Turkmenistan in 2005 to that in 2009?
Your answer should be very brief. 0.29. What is the ratio of the Taxes (in US$) of Uruguay in 2005 to that in 2009?
Offer a terse response. 0.65. What is the ratio of the Taxes (in US$) of Afghanistan in 2006 to that in 2007?
Offer a very short reply. 175.2. What is the ratio of the Taxes (in US$) of Kazakhstan in 2006 to that in 2007?
Ensure brevity in your answer.  0.72. What is the ratio of the Taxes (in US$) of Turkmenistan in 2006 to that in 2007?
Your answer should be compact. 1.01. What is the ratio of the Taxes (in US$) of Uruguay in 2006 to that in 2007?
Ensure brevity in your answer.  0.88. What is the ratio of the Taxes (in US$) of Afghanistan in 2006 to that in 2008?
Offer a terse response. 161.31. What is the ratio of the Taxes (in US$) in Kazakhstan in 2006 to that in 2008?
Your answer should be very brief. 0.59. What is the ratio of the Taxes (in US$) of Turkmenistan in 2006 to that in 2008?
Keep it short and to the point. 0.42. What is the ratio of the Taxes (in US$) of Uruguay in 2006 to that in 2008?
Provide a succinct answer. 0.82. What is the ratio of the Taxes (in US$) of Afghanistan in 2006 to that in 2009?
Provide a short and direct response. 106.12. What is the ratio of the Taxes (in US$) in Kazakhstan in 2006 to that in 2009?
Make the answer very short. 0.85. What is the ratio of the Taxes (in US$) of Turkmenistan in 2006 to that in 2009?
Provide a short and direct response. 0.35. What is the ratio of the Taxes (in US$) of Uruguay in 2006 to that in 2009?
Offer a very short reply. 0.77. What is the ratio of the Taxes (in US$) of Afghanistan in 2007 to that in 2008?
Provide a succinct answer. 0.92. What is the ratio of the Taxes (in US$) in Kazakhstan in 2007 to that in 2008?
Ensure brevity in your answer.  0.82. What is the ratio of the Taxes (in US$) of Turkmenistan in 2007 to that in 2008?
Your response must be concise. 0.41. What is the ratio of the Taxes (in US$) in Uruguay in 2007 to that in 2008?
Offer a very short reply. 0.93. What is the ratio of the Taxes (in US$) in Afghanistan in 2007 to that in 2009?
Offer a very short reply. 0.61. What is the ratio of the Taxes (in US$) of Kazakhstan in 2007 to that in 2009?
Make the answer very short. 1.18. What is the ratio of the Taxes (in US$) of Turkmenistan in 2007 to that in 2009?
Your response must be concise. 0.34. What is the ratio of the Taxes (in US$) of Uruguay in 2007 to that in 2009?
Give a very brief answer. 0.88. What is the ratio of the Taxes (in US$) in Afghanistan in 2008 to that in 2009?
Ensure brevity in your answer.  0.66. What is the ratio of the Taxes (in US$) in Kazakhstan in 2008 to that in 2009?
Keep it short and to the point. 1.44. What is the ratio of the Taxes (in US$) of Turkmenistan in 2008 to that in 2009?
Ensure brevity in your answer.  0.83. What is the ratio of the Taxes (in US$) of Uruguay in 2008 to that in 2009?
Make the answer very short. 0.95. What is the difference between the highest and the second highest Taxes (in US$) of Afghanistan?
Your response must be concise. 2.29e+12. What is the difference between the highest and the second highest Taxes (in US$) in Kazakhstan?
Offer a very short reply. 2.06e+11. What is the difference between the highest and the second highest Taxes (in US$) in Turkmenistan?
Offer a very short reply. 8.25e+07. What is the difference between the highest and the second highest Taxes (in US$) in Uruguay?
Your answer should be compact. 4.51e+09. What is the difference between the highest and the lowest Taxes (in US$) in Afghanistan?
Your answer should be very brief. 2.31e+12. What is the difference between the highest and the lowest Taxes (in US$) of Kazakhstan?
Ensure brevity in your answer.  8.12e+11. What is the difference between the highest and the lowest Taxes (in US$) of Turkmenistan?
Your answer should be compact. 6.44e+08. What is the difference between the highest and the lowest Taxes (in US$) in Uruguay?
Ensure brevity in your answer.  4.63e+1. 